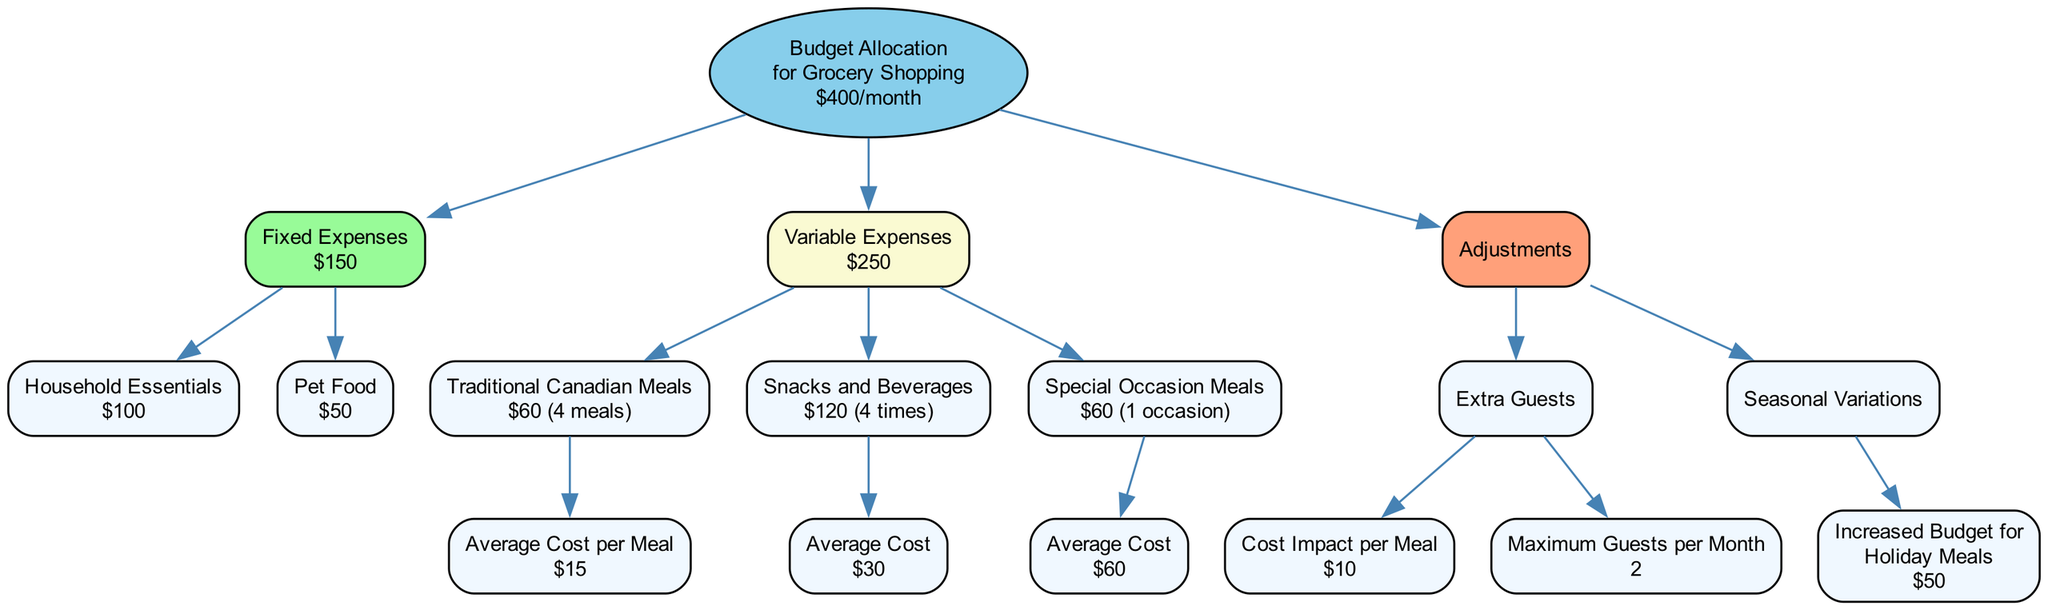What is the total monthly budget for grocery shopping? The diagram starts with the root node indicating the total budget of $400 for grocery shopping each month. This direct information is clearly stated in the root.
Answer: $400 How much is allocated for fixed expenses? In the diagram, the fixed expenses are represented as a child node of the total budget, which shows a total value of $150. This is the sum of household essentials and pet food.
Answer: $150 What is the average cost per traditional Canadian meal? The node for traditional Canadian meals shows the average cost per meal as $15, which is directly stated in the respective box in the diagram.
Answer: $15 What is the total cost for snacks and beverages per month? The diagram indicates snacks and beverages cost $120, derived from the average cost of $30 multiplied by the frequency of 4 times a month.
Answer: $120 What is the maximum number of extra guests that can be accommodated per month? The maximum guests per month is clearly stated as 2 in the "Extra Guests" section of the adjustments, which is connected to the main budget allocation.
Answer: 2 What is the total increased budget for holiday meals? The diagram specifies that the increased budget for holiday meals under seasonal variations is $50, which is shown directly in the respective box.
Answer: $50 If two extra guests are invited for traditional Canadian meals, what is the extra total cost? Each extra guest incurs a cost impact of $10 per meal, for 2 guests and 4 meals. Therefore, this computes as 2 guests * $10 * 4 meals = $80. This is calculated by considering the cost impact and the maximum number of meals.
Answer: $80 How much is spent on special occasion meals per month? The diagram clearly states that the total cost for special occasion meals per month is $60, as indicated directly in the respective node.
Answer: $60 What is the total amount spent on variable expenses? The total for variable expenses is indicated to be $250, which encompasses the costs for traditional Canadian meals, snacks and beverages, and special occasions, directly represented in that section.
Answer: $250 